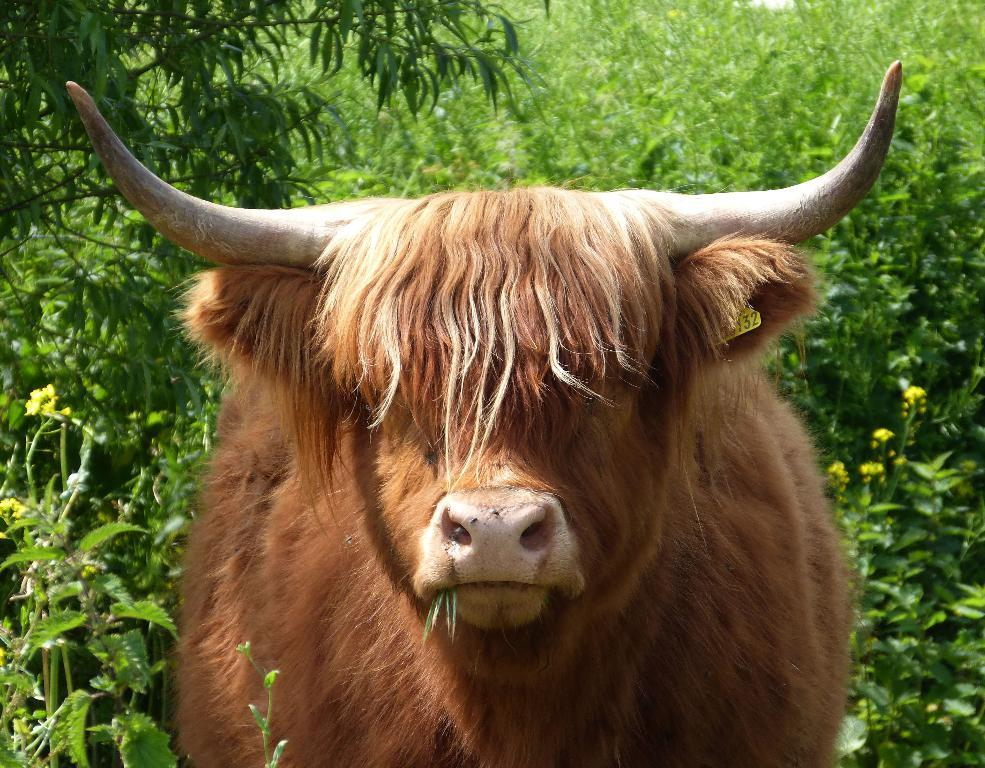What animal can be seen in the image? There is a bull present in the image. What is the position of the bull in the image? The bull is on the ground. What type of vegetation is visible in the image? There are plants and trees present in the image. What type of wealth is depicted in the image? There is no depiction of wealth in the image; it features a bull on the ground with plants and trees in the background. 